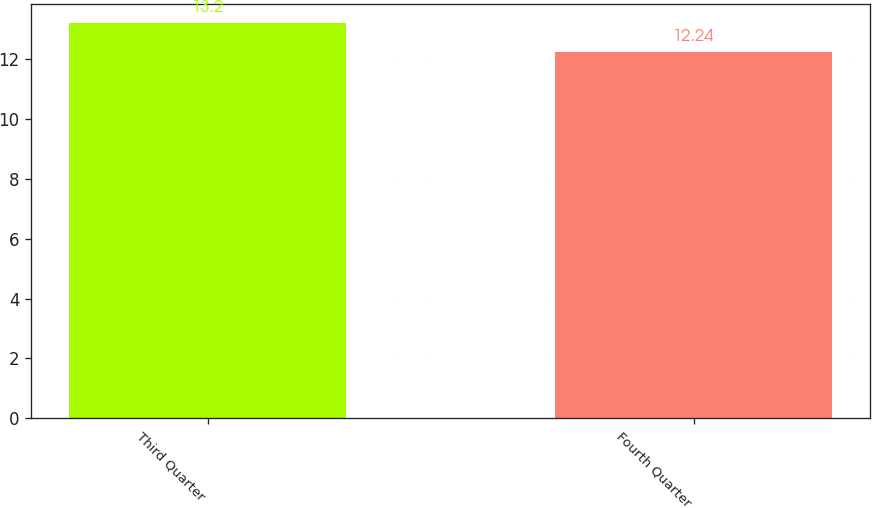<chart> <loc_0><loc_0><loc_500><loc_500><bar_chart><fcel>Third Quarter<fcel>Fourth Quarter<nl><fcel>13.2<fcel>12.24<nl></chart> 